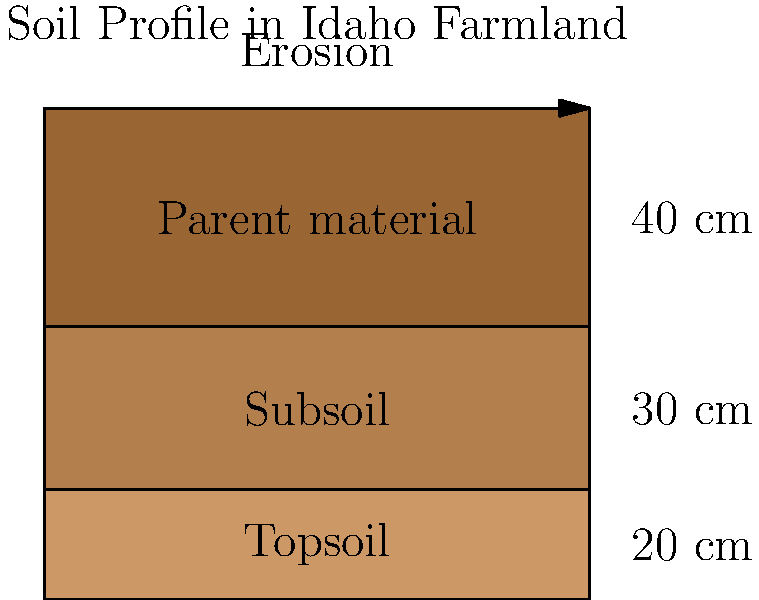Based on the cross-sectional diagram of soil layers in Idaho farmland, if the topsoil erosion rate is 0.5 cm per year, how many years would it take for the entire topsoil layer to erode, assuming no soil conservation measures are implemented? To solve this problem, we need to follow these steps:

1. Identify the thickness of the topsoil layer from the diagram:
   The topsoil layer is shown to be 20 cm thick.

2. Understand the given erosion rate:
   The question states that the topsoil erosion rate is 0.5 cm per year.

3. Calculate the time needed for complete erosion:
   We can use the formula: Time = Total thickness / Erosion rate per year
   
   Time = 20 cm / (0.5 cm/year)
   Time = 40 years

This calculation shows that it would take 40 years for the entire topsoil layer to erode at the given rate, assuming no soil conservation measures are implemented.

It's important to note that this scenario is hypothetical and highlights the significance of soil conservation practices in Idaho's agriculture. In reality, farmers and agricultural experts in Idaho implement various soil conservation techniques to prevent such rapid erosion and maintain soil health for sustainable farming.
Answer: 40 years 